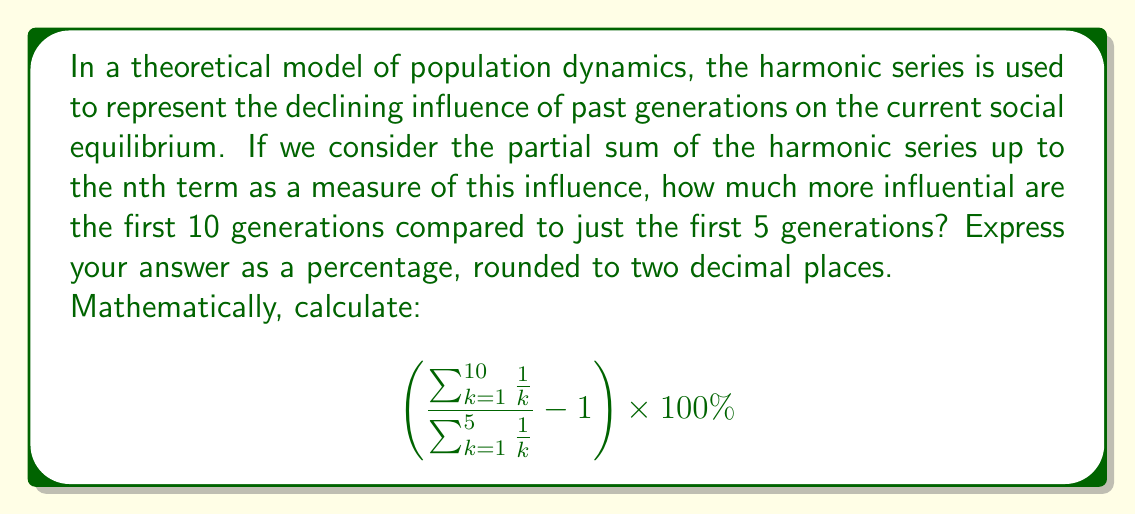Can you solve this math problem? To solve this problem, we need to evaluate the partial sums of the harmonic series for n = 5 and n = 10.

1. First, let's calculate the sum for n = 5:
   $$ \sum_{k=1}^{5} \frac{1}{k} = 1 + \frac{1}{2} + \frac{1}{3} + \frac{1}{4} + \frac{1}{5} = 2.283333... $$

2. Now, let's calculate the sum for n = 10:
   $$ \sum_{k=1}^{10} \frac{1}{k} = 1 + \frac{1}{2} + \frac{1}{3} + \frac{1}{4} + \frac{1}{5} + \frac{1}{6} + \frac{1}{7} + \frac{1}{8} + \frac{1}{9} + \frac{1}{10} = 2.928968... $$

3. Now we can calculate the ratio:
   $$ \frac{\sum_{k=1}^{10} \frac{1}{k}}{\sum_{k=1}^{5} \frac{1}{k}} = \frac{2.928968...}{2.283333...} = 1.282723... $$

4. To express this as a percentage increase, we subtract 1 and multiply by 100:
   $$ (1.282723... - 1) \times 100\% = 0.282723... \times 100\% = 28.2723...% $$

5. Rounding to two decimal places, we get 28.27%.

This result indicates that considering the first 10 generations instead of just the first 5 increases the measure of influence by approximately 28.27%.
Answer: 28.27% 